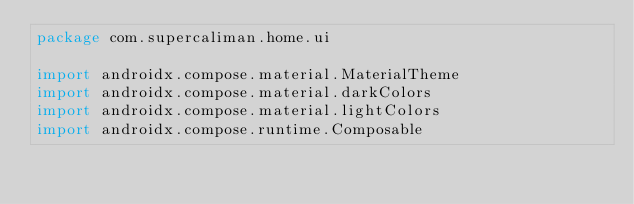<code> <loc_0><loc_0><loc_500><loc_500><_Kotlin_>package com.supercaliman.home.ui

import androidx.compose.material.MaterialTheme
import androidx.compose.material.darkColors
import androidx.compose.material.lightColors
import androidx.compose.runtime.Composable</code> 